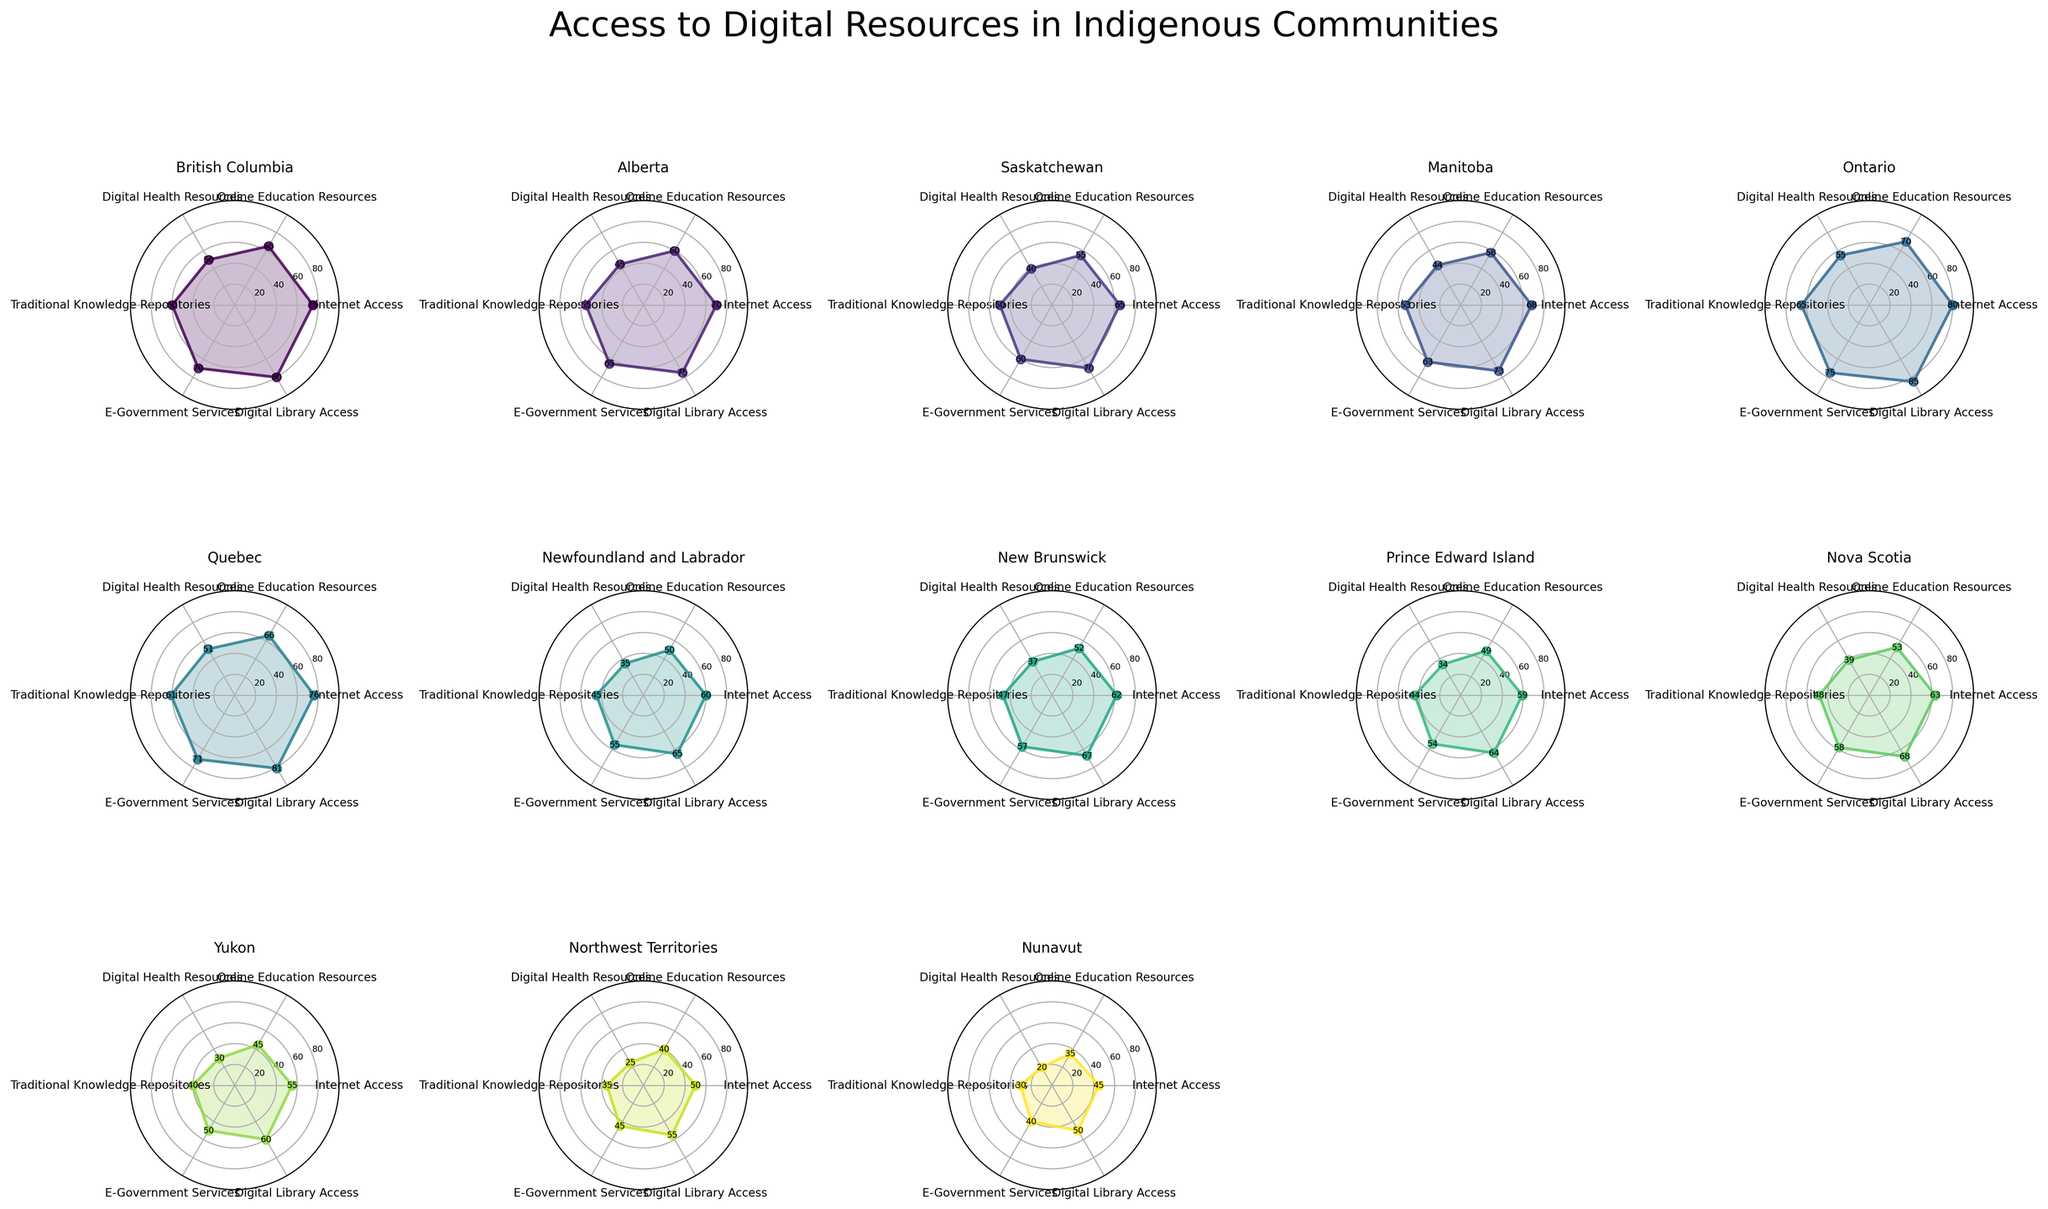What is the title of the figure? The title of the figure is usually located at the top and is the most prominent text in the entire figure. It provides the main topic or focus of the visual representation.
Answer: Access to Digital Resources in Indigenous Communities Which province has the highest Internet access? Referring to the subplots, identify the province where the 'Internet Access' value is the highest. The values can be noted for comparison.
Answer: Ontario How does Online Education Resources in Yukon compare to that in Saskatchewan? Locate the subplots for Yukon and Saskatchewan. For both, identify the value of Online Education Resources and directly compare them.
Answer: Yukon has lower Online Education Resources than Saskatchewan What is the average Digital Library Access across all provinces? Calculate the sum of Digital Library Access values for all the provinces and then divide by the number of provinces (13).
Answer: (80 + 75 + 70 + 73 + 85 + 81 + 65 + 67 + 64 + 68 + 60 + 55 + 50) / 13 = ~68.23 Which territories have Digital Health Resources below 30? Look at the subplots representing the territories (Yukon, Northwest Territories, Nunavut) and check their values for 'Digital Health Resources'. Determine which are less than 30.
Answer: Yukon, Northwest Territories, Nunavut How does Traditional Knowledge Repositories access in British Columbia compare to that in Alberta? Find the values for Traditional Knowledge Repositories access in both British Columbia and Alberta from their respective subplots. Compare these values.
Answer: British Columbia has higher Traditional Knowledge Repositories access than Alberta What is the range of E-Government Services values across all provinces and territories? Identify the minimum and maximum values for E-Government Services across all subplots, then calculate the difference.
Answer: 75 (highest in Ontario) - 40 (lowest in Nunavut) = 35 Is Digital Health Resources access generally correlated with Online Education Resources? Observe the trends across all subplots to see if provinces with higher Digital Health Resources generally also have higher Online Education Resources.
Answer: Yes, there is a general correlation Which province shows the most balanced access across all digital resources categories? Look at each province's subplot to see which one has the least variation in values across the categories (Internet Access, Online Education Resources, etc.). This would mean the line plot is closest to a regular polygon.
Answer: Ontario What is the difference in Internet Access between the province with the highest and the one with the lowest? Identify the highest and lowest values of Internet Access among the subplots. Subtract the lowest value from the highest value.
Answer: 80 (Ontario) - 45 (Nunavut) = 35 